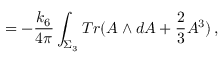<formula> <loc_0><loc_0><loc_500><loc_500>= - \frac { k _ { 6 } } { 4 \pi } \int _ { \Sigma _ { 3 } } T r ( A \wedge d A + \frac { 2 } { 3 } A ^ { 3 } ) \, ,</formula> 